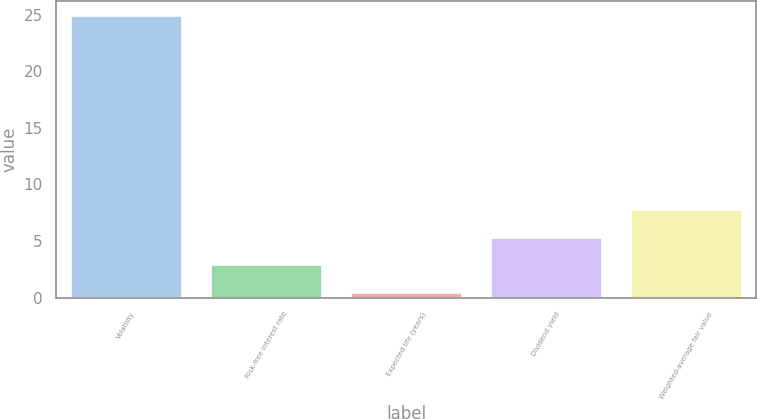Convert chart. <chart><loc_0><loc_0><loc_500><loc_500><bar_chart><fcel>Volatility<fcel>Risk-free interest rate<fcel>Expected life (years)<fcel>Dividend yield<fcel>Weighted-average fair value<nl><fcel>25<fcel>2.95<fcel>0.5<fcel>5.4<fcel>7.85<nl></chart> 